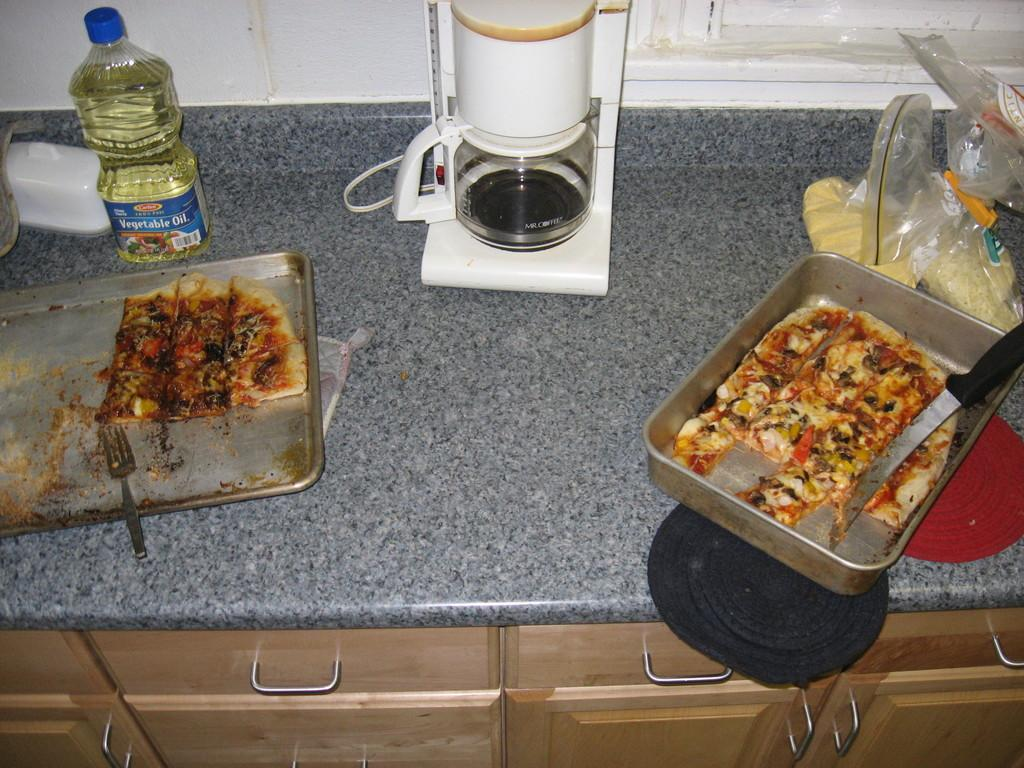<image>
Provide a brief description of the given image. pans of pizza on a counter with a bottle of VEGETABLE OIL 